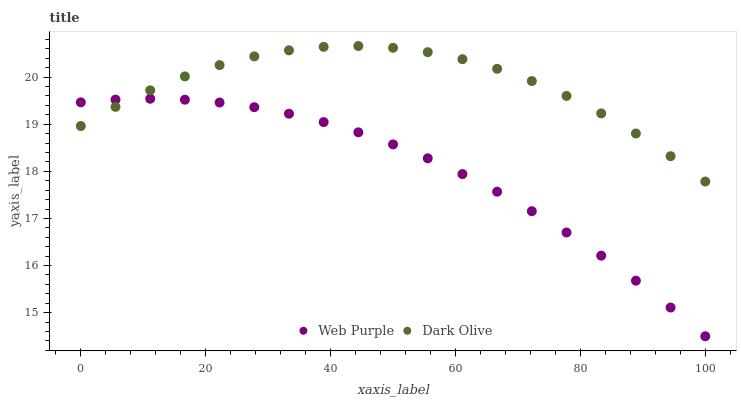Does Web Purple have the minimum area under the curve?
Answer yes or no. Yes. Does Dark Olive have the maximum area under the curve?
Answer yes or no. Yes. Does Dark Olive have the minimum area under the curve?
Answer yes or no. No. Is Web Purple the smoothest?
Answer yes or no. Yes. Is Dark Olive the roughest?
Answer yes or no. Yes. Is Dark Olive the smoothest?
Answer yes or no. No. Does Web Purple have the lowest value?
Answer yes or no. Yes. Does Dark Olive have the lowest value?
Answer yes or no. No. Does Dark Olive have the highest value?
Answer yes or no. Yes. Does Web Purple intersect Dark Olive?
Answer yes or no. Yes. Is Web Purple less than Dark Olive?
Answer yes or no. No. Is Web Purple greater than Dark Olive?
Answer yes or no. No. 